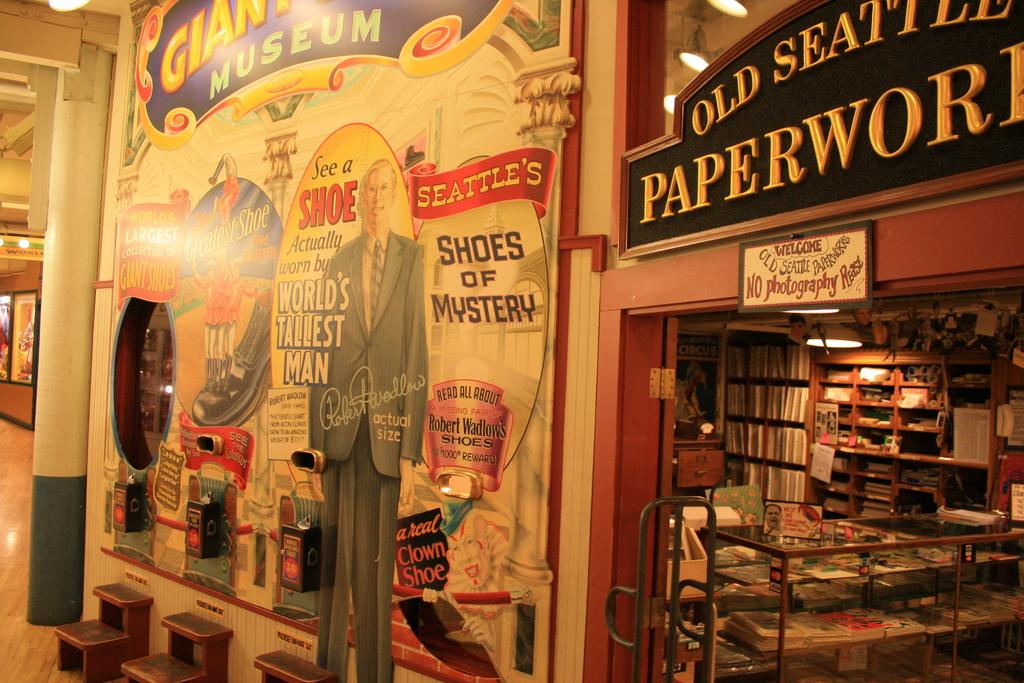What is the name of this store?
Make the answer very short. Old seattle paperwork. Can you take photographs in the store?
Keep it short and to the point. No. 